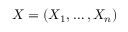Convert formula to latex. <formula><loc_0><loc_0><loc_500><loc_500>X = ( X _ { 1 } , \dots , X _ { n } )</formula> 